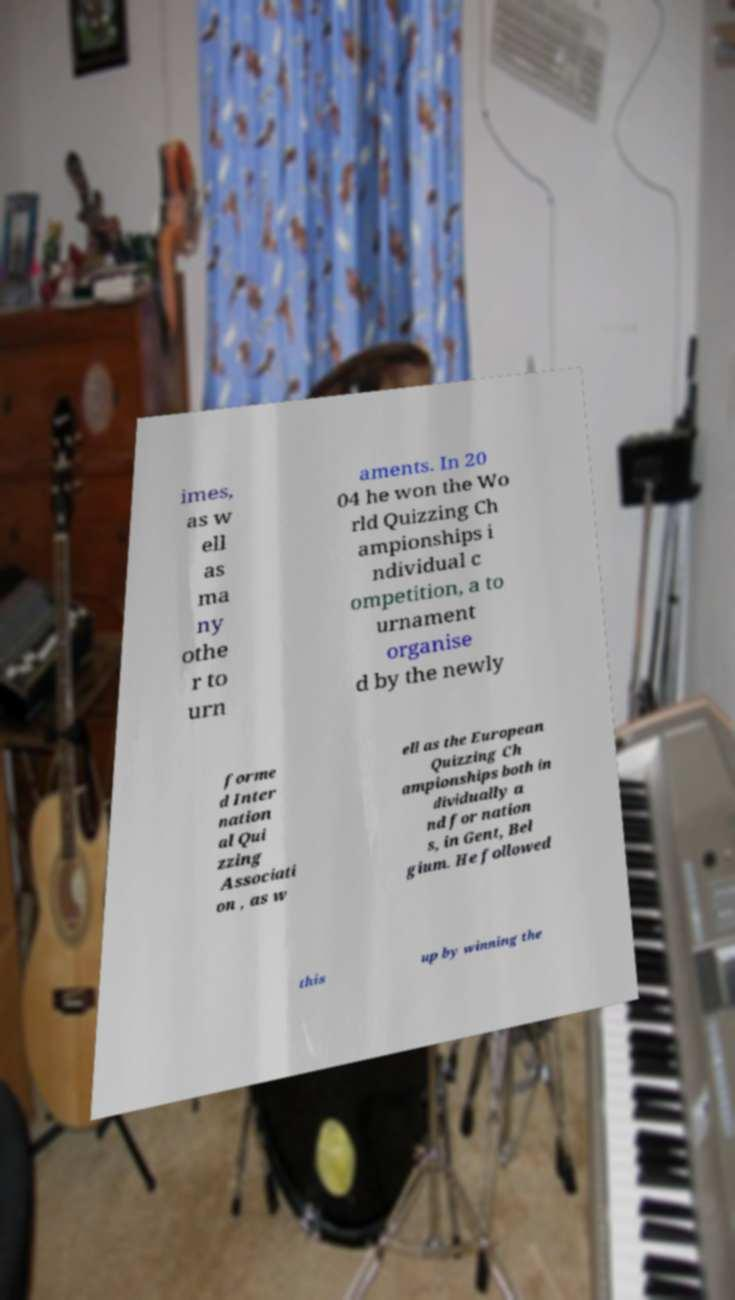Please identify and transcribe the text found in this image. imes, as w ell as ma ny othe r to urn aments. In 20 04 he won the Wo rld Quizzing Ch ampionships i ndividual c ompetition, a to urnament organise d by the newly forme d Inter nation al Qui zzing Associati on , as w ell as the European Quizzing Ch ampionships both in dividually a nd for nation s, in Gent, Bel gium. He followed this up by winning the 